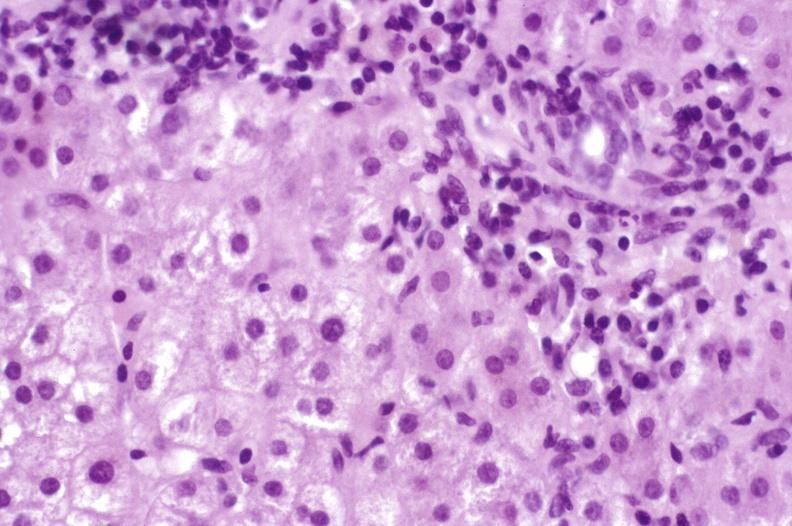what is present?
Answer the question using a single word or phrase. Hepatobiliary 